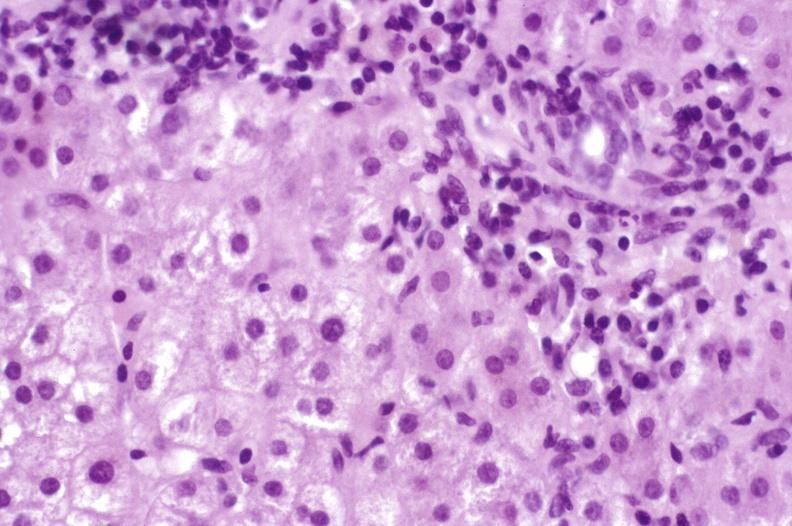what is present?
Answer the question using a single word or phrase. Hepatobiliary 